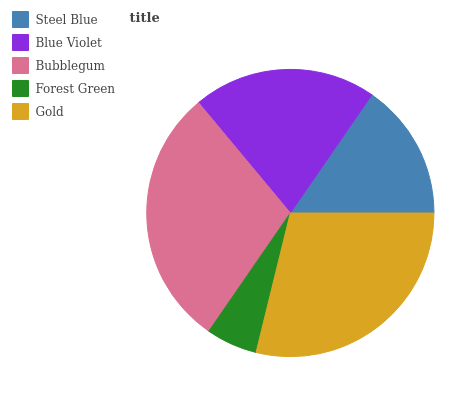Is Forest Green the minimum?
Answer yes or no. Yes. Is Bubblegum the maximum?
Answer yes or no. Yes. Is Blue Violet the minimum?
Answer yes or no. No. Is Blue Violet the maximum?
Answer yes or no. No. Is Blue Violet greater than Steel Blue?
Answer yes or no. Yes. Is Steel Blue less than Blue Violet?
Answer yes or no. Yes. Is Steel Blue greater than Blue Violet?
Answer yes or no. No. Is Blue Violet less than Steel Blue?
Answer yes or no. No. Is Blue Violet the high median?
Answer yes or no. Yes. Is Blue Violet the low median?
Answer yes or no. Yes. Is Bubblegum the high median?
Answer yes or no. No. Is Forest Green the low median?
Answer yes or no. No. 